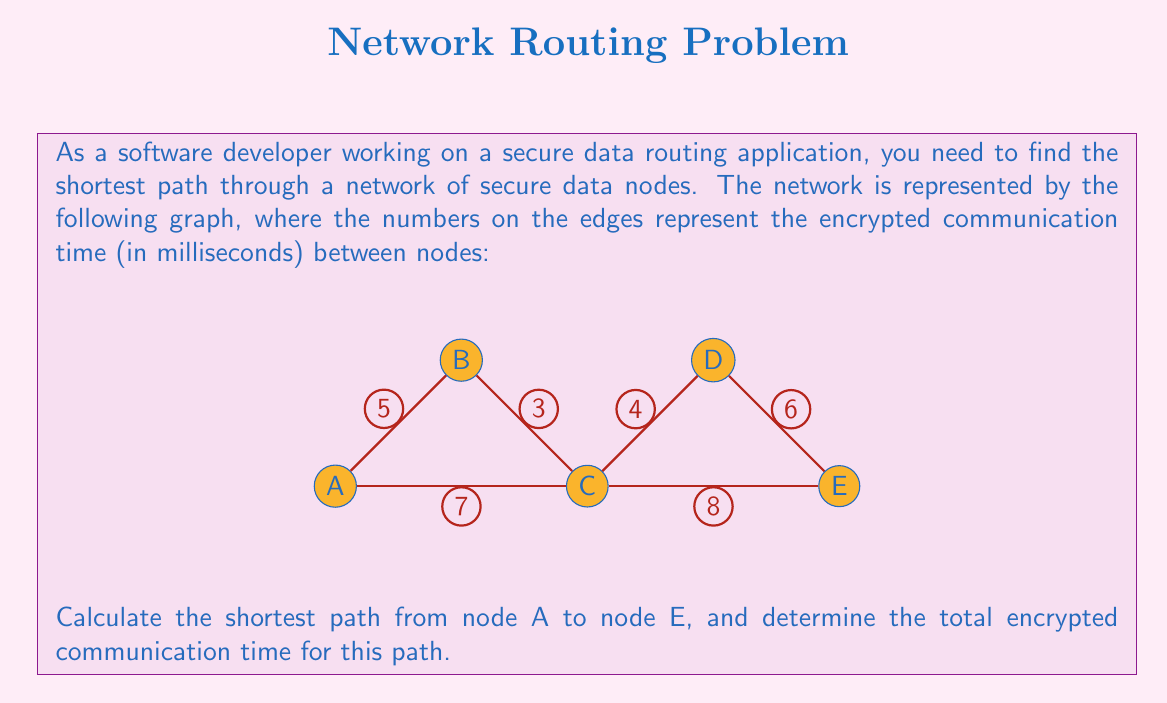Provide a solution to this math problem. To solve this problem, we can use Dijkstra's algorithm or simply compare all possible paths from A to E. Let's compare all paths:

1. Path A-B-C-D-E:
   $5 + 3 + 4 + 6 = 18$ ms

2. Path A-B-C-E:
   $5 + 3 + 8 = 16$ ms

3. Path A-C-D-E:
   $7 + 4 + 6 = 17$ ms

4. Path A-C-E:
   $7 + 8 = 15$ ms

The shortest path is A-C-E, with a total encrypted communication time of 15 ms.

To verify this result, we can use the following mathematical representation:

Let $d(X,Y)$ be the direct distance between nodes X and Y.

The shortest path length $L$ is given by:

$$L = \min\begin{cases}
d(A,B) + d(B,C) + d(C,D) + d(D,E) \\
d(A,B) + d(B,C) + d(C,E) \\
d(A,C) + d(C,D) + d(D,E) \\
d(A,C) + d(C,E)
\end{cases}$$

$$L = \min\begin{cases}
5 + 3 + 4 + 6 = 18 \\
5 + 3 + 8 = 16 \\
7 + 4 + 6 = 17 \\
7 + 8 = 15
\end{cases} = 15$$

Therefore, the shortest path is A-C-E with a total encrypted communication time of 15 ms.
Answer: A-C-E, 15 ms 